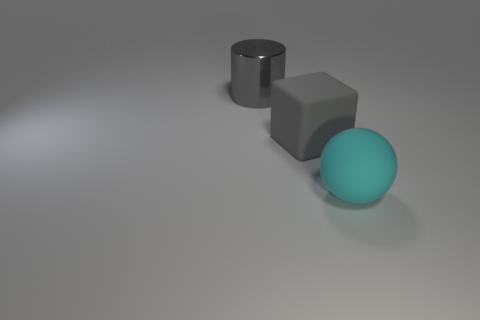Is there anything else that has the same shape as the gray matte object?
Your answer should be compact. No. Is there any other thing that has the same material as the large cylinder?
Your answer should be very brief. No. What is the shape of the big thing that is both behind the large ball and to the right of the gray metallic cylinder?
Ensure brevity in your answer.  Cube. What is the cylinder made of?
Offer a terse response. Metal. What number of cylinders are big matte things or small cyan matte things?
Your response must be concise. 0. Are the big cyan thing and the cylinder made of the same material?
Offer a very short reply. No. Are there an equal number of balls behind the large shiny thing and large brown matte cylinders?
Provide a succinct answer. Yes. What number of objects are big metallic things to the left of the cyan rubber thing or large matte blocks?
Your answer should be compact. 2. There is a matte thing behind the sphere; is it the same color as the shiny object?
Give a very brief answer. Yes. The large object in front of the matte object that is behind the ball is what shape?
Your response must be concise. Sphere. 